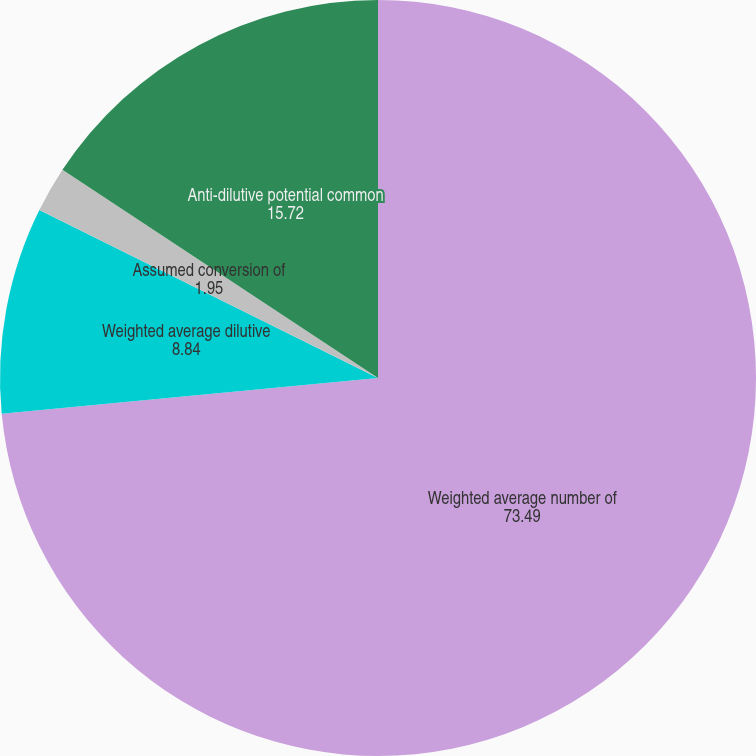Convert chart. <chart><loc_0><loc_0><loc_500><loc_500><pie_chart><fcel>Weighted average number of<fcel>Weighted average dilutive<fcel>Assumed conversion of<fcel>Anti-dilutive potential common<nl><fcel>73.49%<fcel>8.84%<fcel>1.95%<fcel>15.72%<nl></chart> 